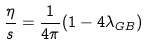Convert formula to latex. <formula><loc_0><loc_0><loc_500><loc_500>\frac { \eta } { s } = \frac { 1 } { 4 \pi } ( 1 - 4 \lambda _ { G B } )</formula> 